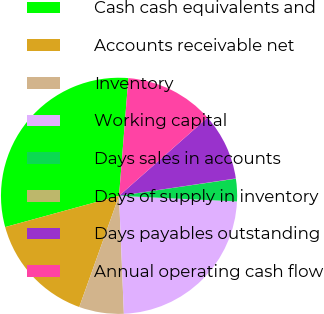Convert chart. <chart><loc_0><loc_0><loc_500><loc_500><pie_chart><fcel>Cash cash equivalents and<fcel>Accounts receivable net<fcel>Inventory<fcel>Working capital<fcel>Days sales in accounts<fcel>Days of supply in inventory<fcel>Days payables outstanding<fcel>Annual operating cash flow<nl><fcel>30.52%<fcel>15.27%<fcel>6.12%<fcel>23.59%<fcel>3.08%<fcel>0.03%<fcel>9.17%<fcel>12.22%<nl></chart> 